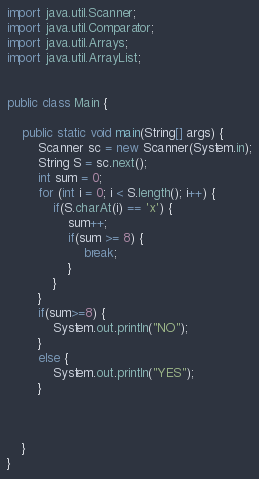Convert code to text. <code><loc_0><loc_0><loc_500><loc_500><_Java_>import java.util.Scanner;
import java.util.Comparator;
import java.util.Arrays;
import java.util.ArrayList;


public class Main {

	public static void main(String[] args) {
		Scanner sc = new Scanner(System.in);
		String S = sc.next();
		int sum = 0;
		for (int i = 0; i < S.length(); i++) {
			if(S.charAt(i) == 'x') {
				sum++;
				if(sum >= 8) {
					break;
				}
			}
		}
		if(sum>=8) {
			System.out.println("NO");
		}
		else {
			System.out.println("YES");
		}
		
		

	}
}	

</code> 